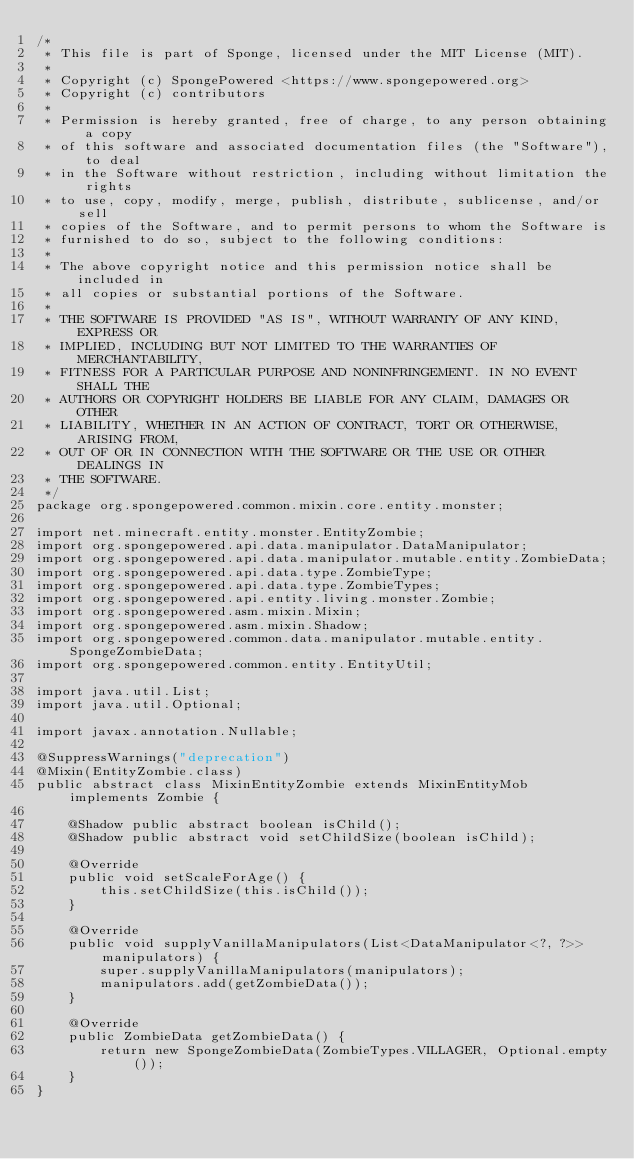<code> <loc_0><loc_0><loc_500><loc_500><_Java_>/*
 * This file is part of Sponge, licensed under the MIT License (MIT).
 *
 * Copyright (c) SpongePowered <https://www.spongepowered.org>
 * Copyright (c) contributors
 *
 * Permission is hereby granted, free of charge, to any person obtaining a copy
 * of this software and associated documentation files (the "Software"), to deal
 * in the Software without restriction, including without limitation the rights
 * to use, copy, modify, merge, publish, distribute, sublicense, and/or sell
 * copies of the Software, and to permit persons to whom the Software is
 * furnished to do so, subject to the following conditions:
 *
 * The above copyright notice and this permission notice shall be included in
 * all copies or substantial portions of the Software.
 *
 * THE SOFTWARE IS PROVIDED "AS IS", WITHOUT WARRANTY OF ANY KIND, EXPRESS OR
 * IMPLIED, INCLUDING BUT NOT LIMITED TO THE WARRANTIES OF MERCHANTABILITY,
 * FITNESS FOR A PARTICULAR PURPOSE AND NONINFRINGEMENT. IN NO EVENT SHALL THE
 * AUTHORS OR COPYRIGHT HOLDERS BE LIABLE FOR ANY CLAIM, DAMAGES OR OTHER
 * LIABILITY, WHETHER IN AN ACTION OF CONTRACT, TORT OR OTHERWISE, ARISING FROM,
 * OUT OF OR IN CONNECTION WITH THE SOFTWARE OR THE USE OR OTHER DEALINGS IN
 * THE SOFTWARE.
 */
package org.spongepowered.common.mixin.core.entity.monster;

import net.minecraft.entity.monster.EntityZombie;
import org.spongepowered.api.data.manipulator.DataManipulator;
import org.spongepowered.api.data.manipulator.mutable.entity.ZombieData;
import org.spongepowered.api.data.type.ZombieType;
import org.spongepowered.api.data.type.ZombieTypes;
import org.spongepowered.api.entity.living.monster.Zombie;
import org.spongepowered.asm.mixin.Mixin;
import org.spongepowered.asm.mixin.Shadow;
import org.spongepowered.common.data.manipulator.mutable.entity.SpongeZombieData;
import org.spongepowered.common.entity.EntityUtil;

import java.util.List;
import java.util.Optional;

import javax.annotation.Nullable;

@SuppressWarnings("deprecation")
@Mixin(EntityZombie.class)
public abstract class MixinEntityZombie extends MixinEntityMob implements Zombie {

    @Shadow public abstract boolean isChild();
    @Shadow public abstract void setChildSize(boolean isChild);

    @Override
    public void setScaleForAge() {
        this.setChildSize(this.isChild());
    }

    @Override
    public void supplyVanillaManipulators(List<DataManipulator<?, ?>> manipulators) {
        super.supplyVanillaManipulators(manipulators);
        manipulators.add(getZombieData());
    }

    @Override
    public ZombieData getZombieData() {
        return new SpongeZombieData(ZombieTypes.VILLAGER, Optional.empty());
    }
}
</code> 